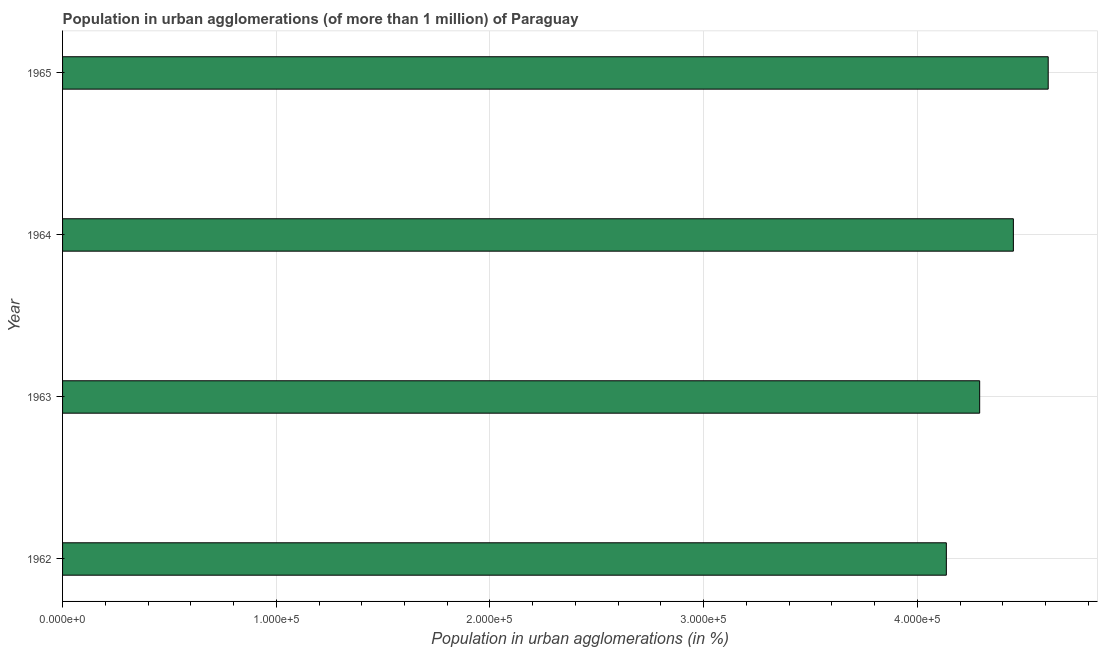Does the graph contain any zero values?
Make the answer very short. No. Does the graph contain grids?
Make the answer very short. Yes. What is the title of the graph?
Offer a terse response. Population in urban agglomerations (of more than 1 million) of Paraguay. What is the label or title of the X-axis?
Provide a succinct answer. Population in urban agglomerations (in %). What is the population in urban agglomerations in 1963?
Keep it short and to the point. 4.29e+05. Across all years, what is the maximum population in urban agglomerations?
Your answer should be very brief. 4.61e+05. Across all years, what is the minimum population in urban agglomerations?
Give a very brief answer. 4.14e+05. In which year was the population in urban agglomerations maximum?
Your answer should be very brief. 1965. In which year was the population in urban agglomerations minimum?
Make the answer very short. 1962. What is the sum of the population in urban agglomerations?
Offer a terse response. 1.75e+06. What is the difference between the population in urban agglomerations in 1962 and 1963?
Ensure brevity in your answer.  -1.56e+04. What is the average population in urban agglomerations per year?
Your answer should be very brief. 4.37e+05. What is the median population in urban agglomerations?
Your answer should be compact. 4.37e+05. In how many years, is the population in urban agglomerations greater than 40000 %?
Make the answer very short. 4. Do a majority of the years between 1965 and 1963 (inclusive) have population in urban agglomerations greater than 360000 %?
Provide a short and direct response. Yes. What is the ratio of the population in urban agglomerations in 1962 to that in 1964?
Give a very brief answer. 0.93. Is the population in urban agglomerations in 1962 less than that in 1963?
Your answer should be very brief. Yes. Is the difference between the population in urban agglomerations in 1964 and 1965 greater than the difference between any two years?
Provide a succinct answer. No. What is the difference between the highest and the second highest population in urban agglomerations?
Keep it short and to the point. 1.63e+04. Is the sum of the population in urban agglomerations in 1962 and 1963 greater than the maximum population in urban agglomerations across all years?
Your answer should be very brief. Yes. What is the difference between the highest and the lowest population in urban agglomerations?
Provide a short and direct response. 4.77e+04. How many bars are there?
Your response must be concise. 4. How many years are there in the graph?
Keep it short and to the point. 4. What is the difference between two consecutive major ticks on the X-axis?
Offer a very short reply. 1.00e+05. What is the Population in urban agglomerations (in %) of 1962?
Provide a short and direct response. 4.14e+05. What is the Population in urban agglomerations (in %) of 1963?
Provide a succinct answer. 4.29e+05. What is the Population in urban agglomerations (in %) of 1964?
Keep it short and to the point. 4.45e+05. What is the Population in urban agglomerations (in %) of 1965?
Your response must be concise. 4.61e+05. What is the difference between the Population in urban agglomerations (in %) in 1962 and 1963?
Give a very brief answer. -1.56e+04. What is the difference between the Population in urban agglomerations (in %) in 1962 and 1964?
Provide a short and direct response. -3.14e+04. What is the difference between the Population in urban agglomerations (in %) in 1962 and 1965?
Offer a terse response. -4.77e+04. What is the difference between the Population in urban agglomerations (in %) in 1963 and 1964?
Offer a very short reply. -1.58e+04. What is the difference between the Population in urban agglomerations (in %) in 1963 and 1965?
Offer a terse response. -3.21e+04. What is the difference between the Population in urban agglomerations (in %) in 1964 and 1965?
Provide a succinct answer. -1.63e+04. What is the ratio of the Population in urban agglomerations (in %) in 1962 to that in 1963?
Keep it short and to the point. 0.96. What is the ratio of the Population in urban agglomerations (in %) in 1962 to that in 1964?
Offer a very short reply. 0.93. What is the ratio of the Population in urban agglomerations (in %) in 1962 to that in 1965?
Make the answer very short. 0.9. What is the ratio of the Population in urban agglomerations (in %) in 1963 to that in 1964?
Provide a short and direct response. 0.96. What is the ratio of the Population in urban agglomerations (in %) in 1964 to that in 1965?
Your answer should be compact. 0.96. 